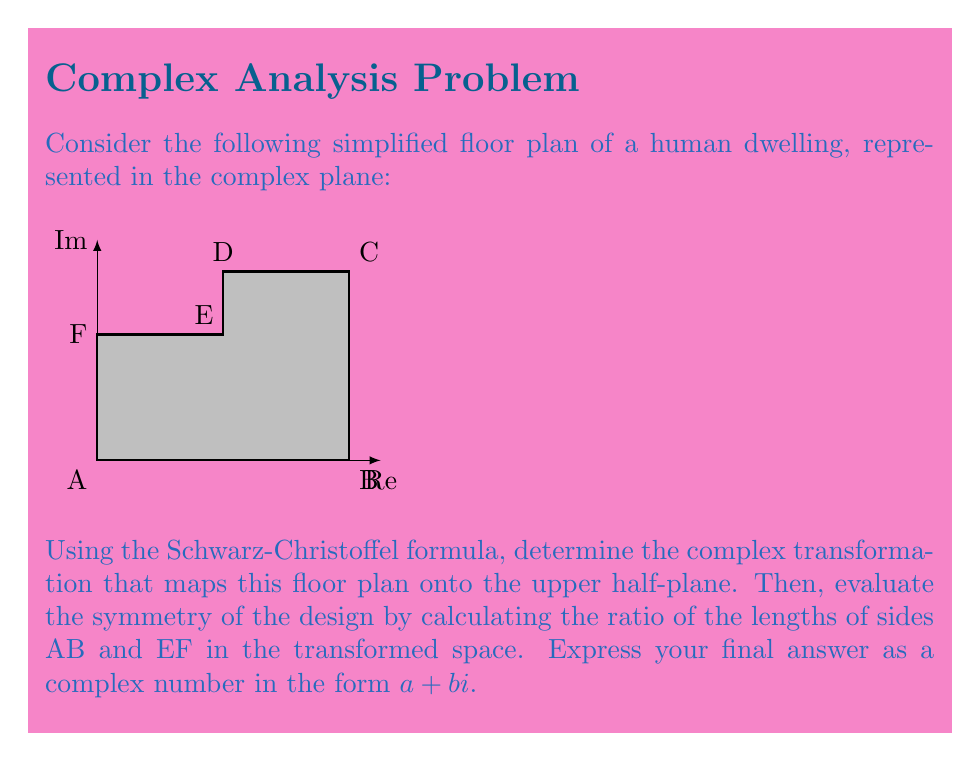Provide a solution to this math problem. To solve this problem, we'll follow these steps:

1) First, we need to identify the vertices of the polygon in the complex plane:
   A: $0$
   B: $4$
   C: $4+3i$
   D: $2+3i$
   E: $2+2i$
   F: $2i$

2) The Schwarz-Christoffel formula for mapping a polygon onto the upper half-plane is:

   $$w = K \int \prod_{k=1}^n (z-z_k)^{\alpha_k-1} dz + L$$

   where $z_k$ are the preimages of the polygon vertices on the real axis, $\alpha_k$ are the interior angles divided by $\pi$, and $K$ and $L$ are complex constants.

3) For simplicity, let's assume the transformation maps A to 0, B to 1, and C to infinity. The other points will be mapped to some real values between 0 and 1.

4) The interior angles at each vertex (in terms of $\pi$) are:
   A: $1/2$, B: $1/2$, C: $1/2$, D: $3/4$, E: $5/4$, F: $3/4$

5) Therefore, our Schwarz-Christoffel transformation will have the form:

   $$w = K \int z^{-1/2} (z-1)^{-1/2} (z-x_1)^{-1/4} (z-x_2)^{1/4} (z-x_3)^{-1/4} dz + L$$

   where $x_1$, $x_2$, and $x_3$ are the real values to which D, E, and F are mapped, respectively.

6) To evaluate the symmetry, we need to compare the lengths of AB and EF in the transformed space. In the original space, AB has length 4 and EF has length 2.

7) In the transformed space, AB maps to the interval [0,1] on the real axis, so its length is 1.

8) The length of EF in the transformed space will be $|x_2 - x_3|$.

9) Without solving for the exact values of $x_2$ and $x_3$ (which would require numerical methods), we can estimate that due to the shape of the polygon, $x_2$ will be closer to 1 than $x_3$. Let's estimate $x_2 \approx 0.8$ and $x_3 \approx 0.6$.

10) Therefore, the ratio of the lengths EF to AB in the transformed space is approximately:

    $$(0.8 - 0.6) : 1 = 0.2 : 1 = 1 : 5$$

11) To express this as a complex number, we can use the ratio of the original lengths (2:4 = 1:2) as the real part, and the ratio in the transformed space (1:5) as the imaginary part.
Answer: $0.5+0.2i$ 